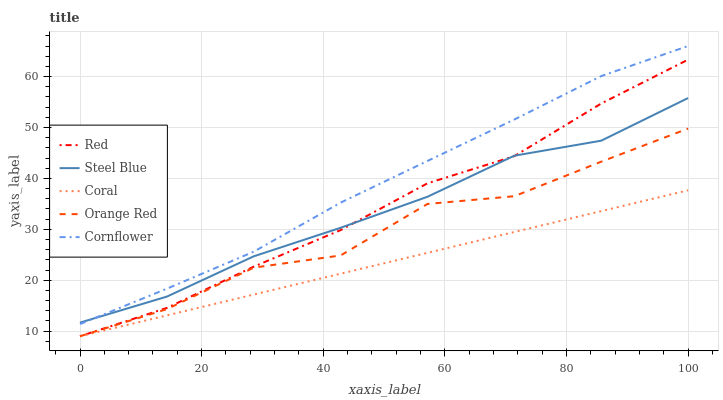Does Coral have the minimum area under the curve?
Answer yes or no. Yes. Does Cornflower have the maximum area under the curve?
Answer yes or no. Yes. Does Steel Blue have the minimum area under the curve?
Answer yes or no. No. Does Steel Blue have the maximum area under the curve?
Answer yes or no. No. Is Coral the smoothest?
Answer yes or no. Yes. Is Orange Red the roughest?
Answer yes or no. Yes. Is Steel Blue the smoothest?
Answer yes or no. No. Is Steel Blue the roughest?
Answer yes or no. No. Does Steel Blue have the lowest value?
Answer yes or no. No. Does Cornflower have the highest value?
Answer yes or no. Yes. Does Steel Blue have the highest value?
Answer yes or no. No. Is Orange Red less than Steel Blue?
Answer yes or no. Yes. Is Cornflower greater than Orange Red?
Answer yes or no. Yes. Does Orange Red intersect Coral?
Answer yes or no. Yes. Is Orange Red less than Coral?
Answer yes or no. No. Is Orange Red greater than Coral?
Answer yes or no. No. Does Orange Red intersect Steel Blue?
Answer yes or no. No. 